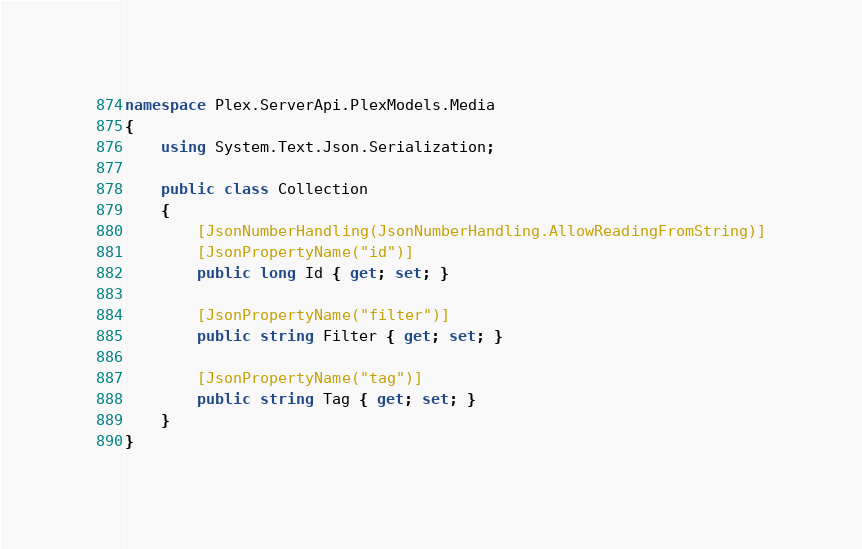Convert code to text. <code><loc_0><loc_0><loc_500><loc_500><_C#_>namespace Plex.ServerApi.PlexModels.Media
{
    using System.Text.Json.Serialization;

    public class Collection
    {
        [JsonNumberHandling(JsonNumberHandling.AllowReadingFromString)]
        [JsonPropertyName("id")]
        public long Id { get; set; }

        [JsonPropertyName("filter")]
        public string Filter { get; set; }

        [JsonPropertyName("tag")]
        public string Tag { get; set; }
    }
}
</code> 